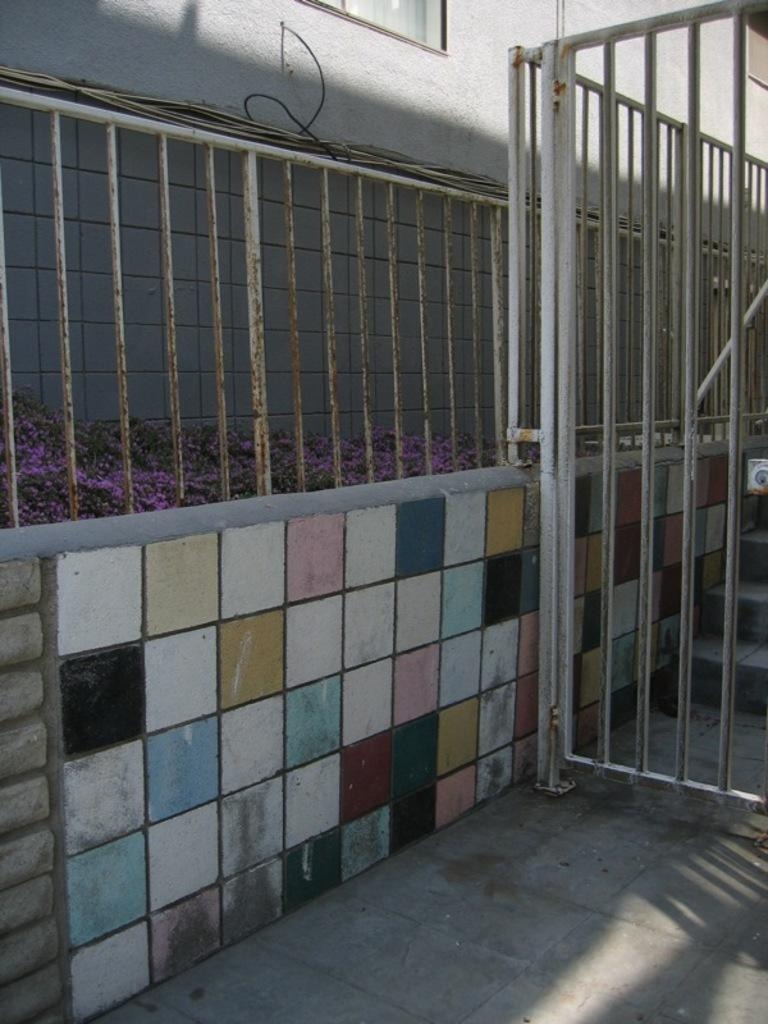What can be observed about the wall in the image? The wall in the image has multiple colors. What is located on the right side of the image? There is a white railing on the right side of the image. What is on the left side of the image? There is a white wall on the left side of the image. How many friends are sitting on the island in the image? There is no island or friends present in the image. What type of snakes can be seen slithering on the wall in the image? There are no snakes visible in the image; the wall has multiple colors. 